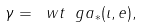<formula> <loc_0><loc_0><loc_500><loc_500>\gamma = \ w t \ g a _ { * } ( \iota , e ) ,</formula> 